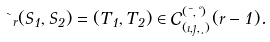<formula> <loc_0><loc_0><loc_500><loc_500>\theta _ { r } ( S _ { 1 } , S _ { 2 } ) = ( T _ { 1 } , T _ { 2 } ) \in \mathcal { C } ^ { ( \mu , \nu ) } _ { ( \zeta , \eta , \xi ) } ( r - 1 ) .</formula> 